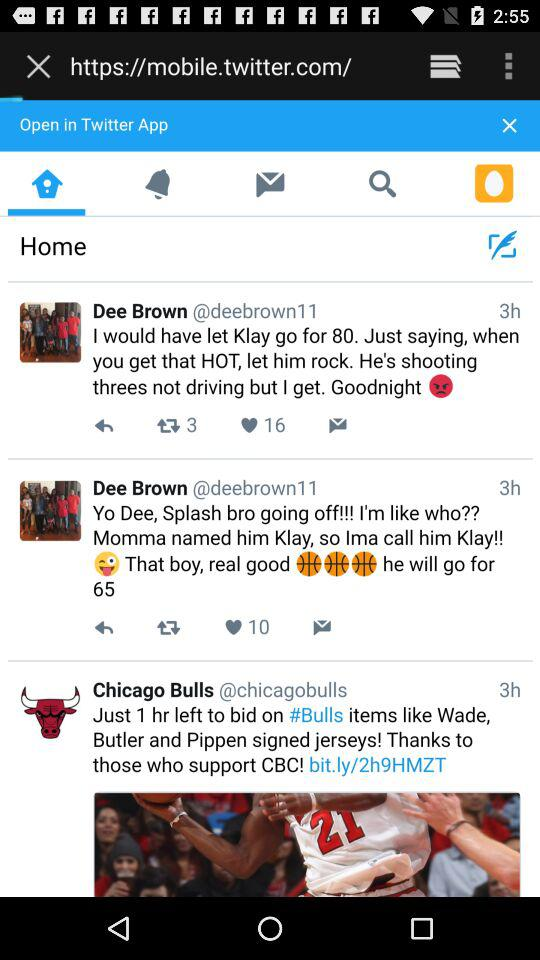When was the post by Dee Brown posted? The post was posted 3 hours ago. 